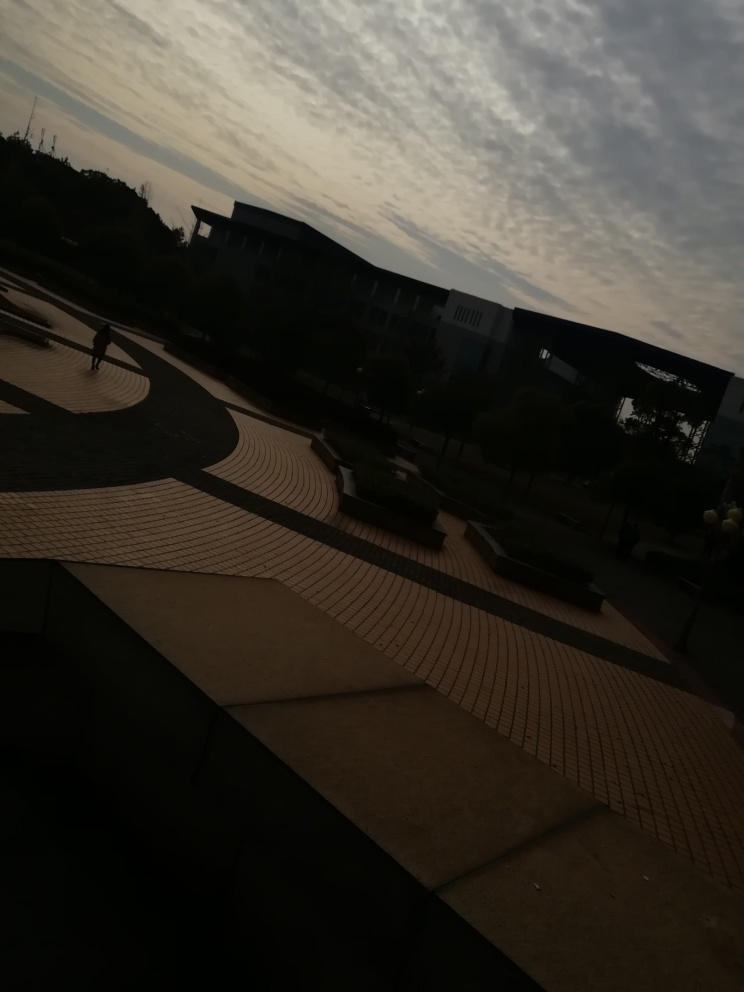Is the clarity of this photo high?
A. No
B. Yes
Answer with the option's letter from the given choices directly. A. The photo's clarity is not high. The image appears underexposed, making the details hard to discern, especially in areas with shadows. A well-exposed photo would have more balanced lighting and visible details. 